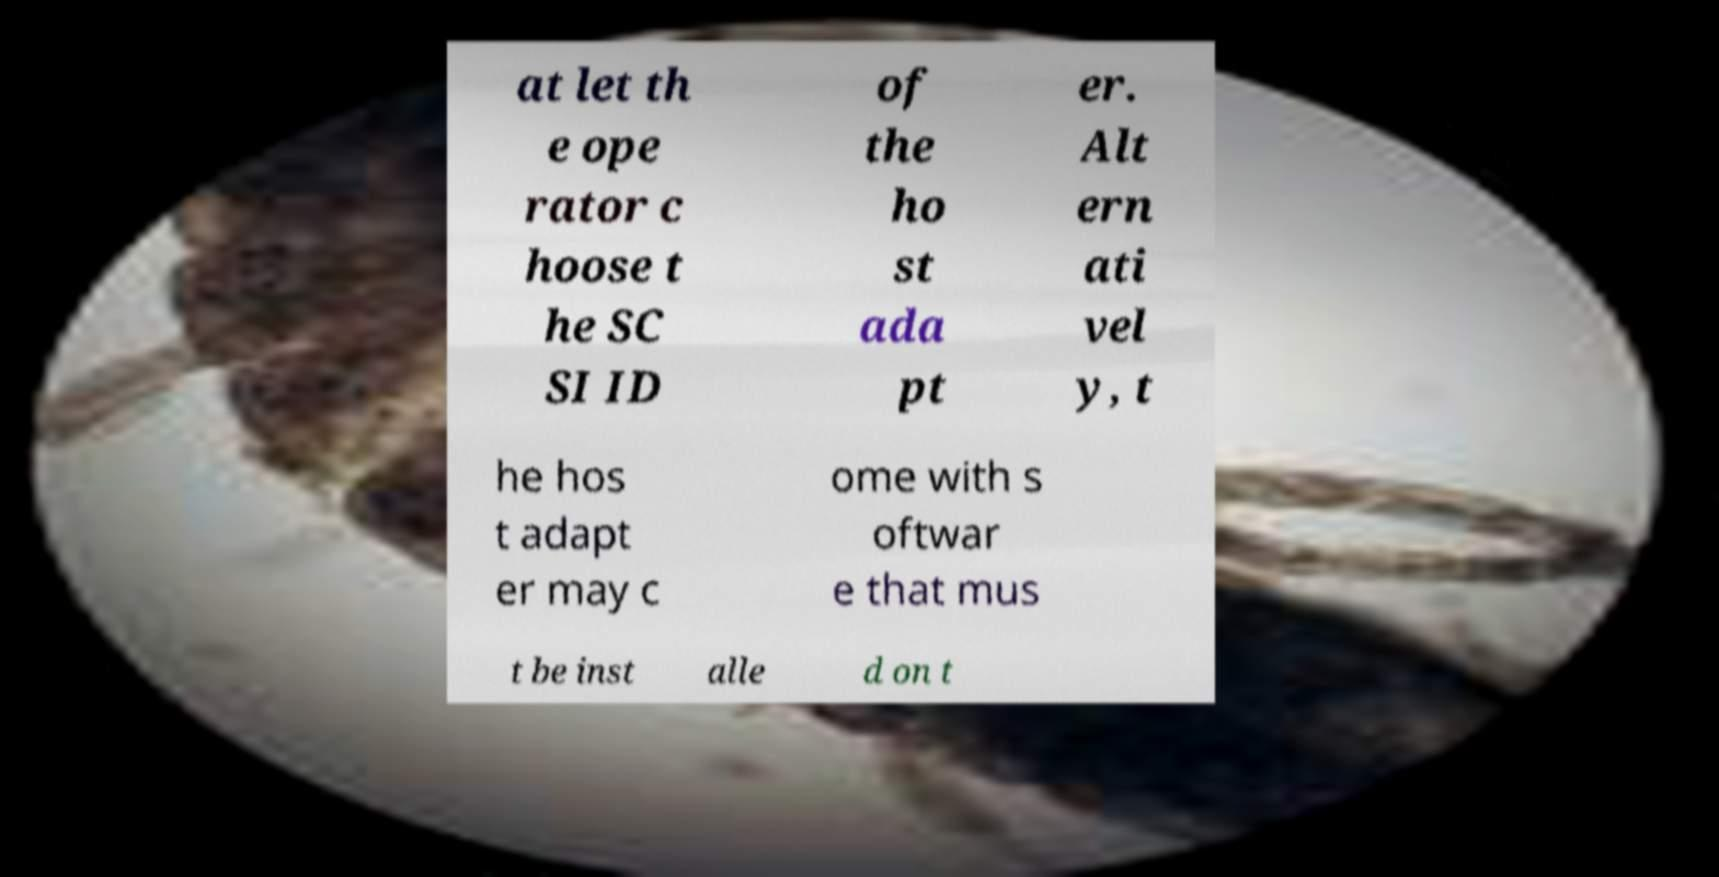Can you read and provide the text displayed in the image?This photo seems to have some interesting text. Can you extract and type it out for me? at let th e ope rator c hoose t he SC SI ID of the ho st ada pt er. Alt ern ati vel y, t he hos t adapt er may c ome with s oftwar e that mus t be inst alle d on t 